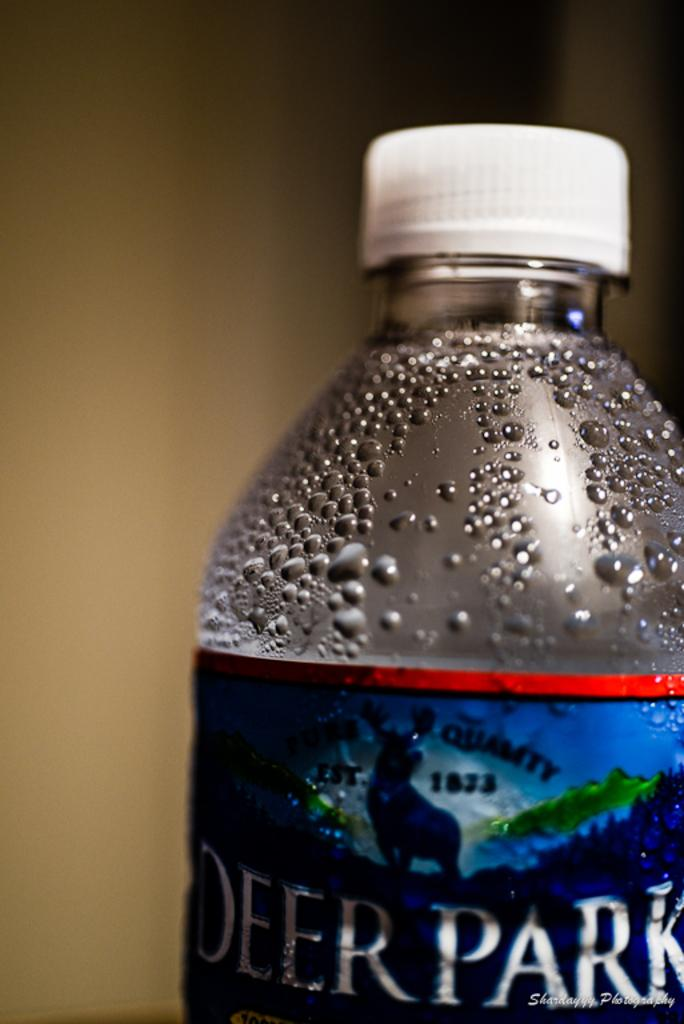<image>
Give a short and clear explanation of the subsequent image. A bottle of Deer Park water has a white lid on it. 